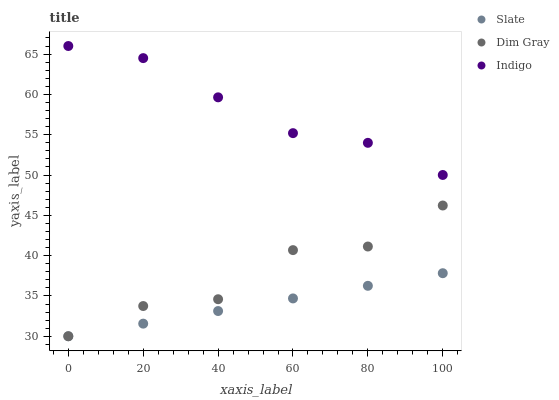Does Slate have the minimum area under the curve?
Answer yes or no. Yes. Does Indigo have the maximum area under the curve?
Answer yes or no. Yes. Does Dim Gray have the minimum area under the curve?
Answer yes or no. No. Does Dim Gray have the maximum area under the curve?
Answer yes or no. No. Is Slate the smoothest?
Answer yes or no. Yes. Is Dim Gray the roughest?
Answer yes or no. Yes. Is Indigo the smoothest?
Answer yes or no. No. Is Indigo the roughest?
Answer yes or no. No. Does Slate have the lowest value?
Answer yes or no. Yes. Does Indigo have the lowest value?
Answer yes or no. No. Does Indigo have the highest value?
Answer yes or no. Yes. Does Dim Gray have the highest value?
Answer yes or no. No. Is Dim Gray less than Indigo?
Answer yes or no. Yes. Is Indigo greater than Dim Gray?
Answer yes or no. Yes. Does Dim Gray intersect Slate?
Answer yes or no. Yes. Is Dim Gray less than Slate?
Answer yes or no. No. Is Dim Gray greater than Slate?
Answer yes or no. No. Does Dim Gray intersect Indigo?
Answer yes or no. No. 